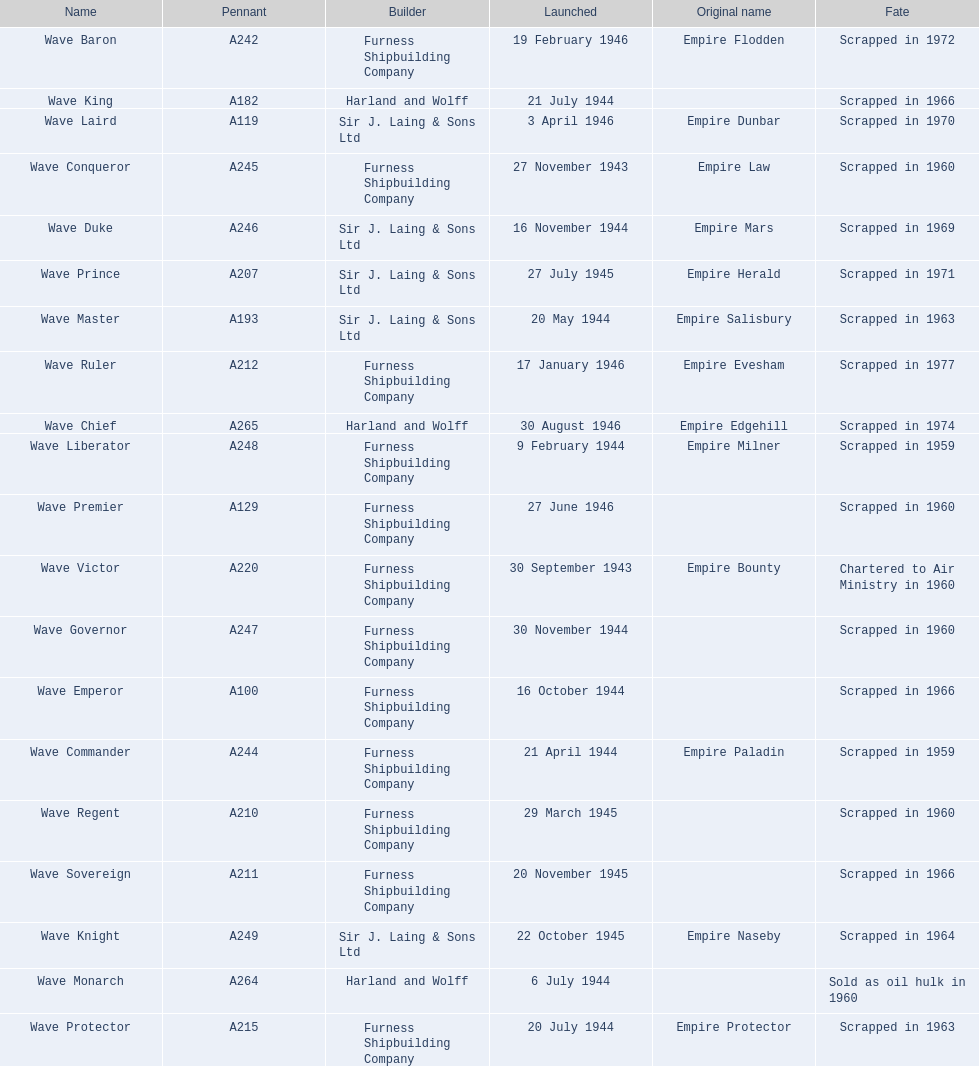How many ships were launched in the year 1944? 9. 